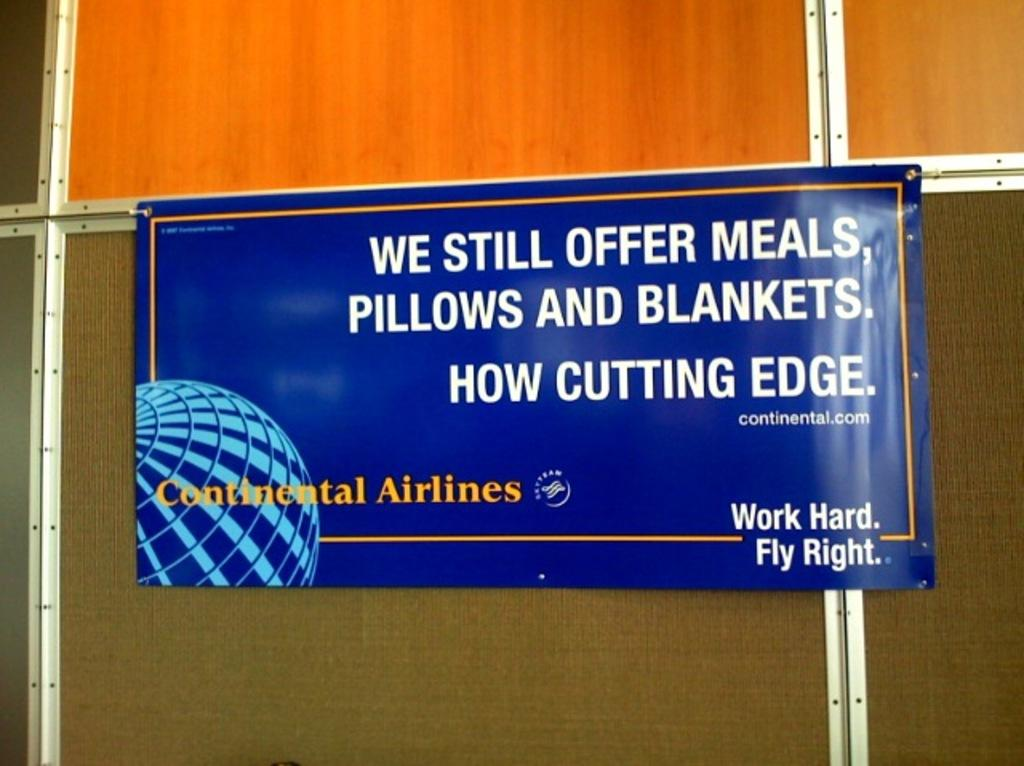Provide a one-sentence caption for the provided image. A blue sign that says Continental Airlines is nailed to a wall. 